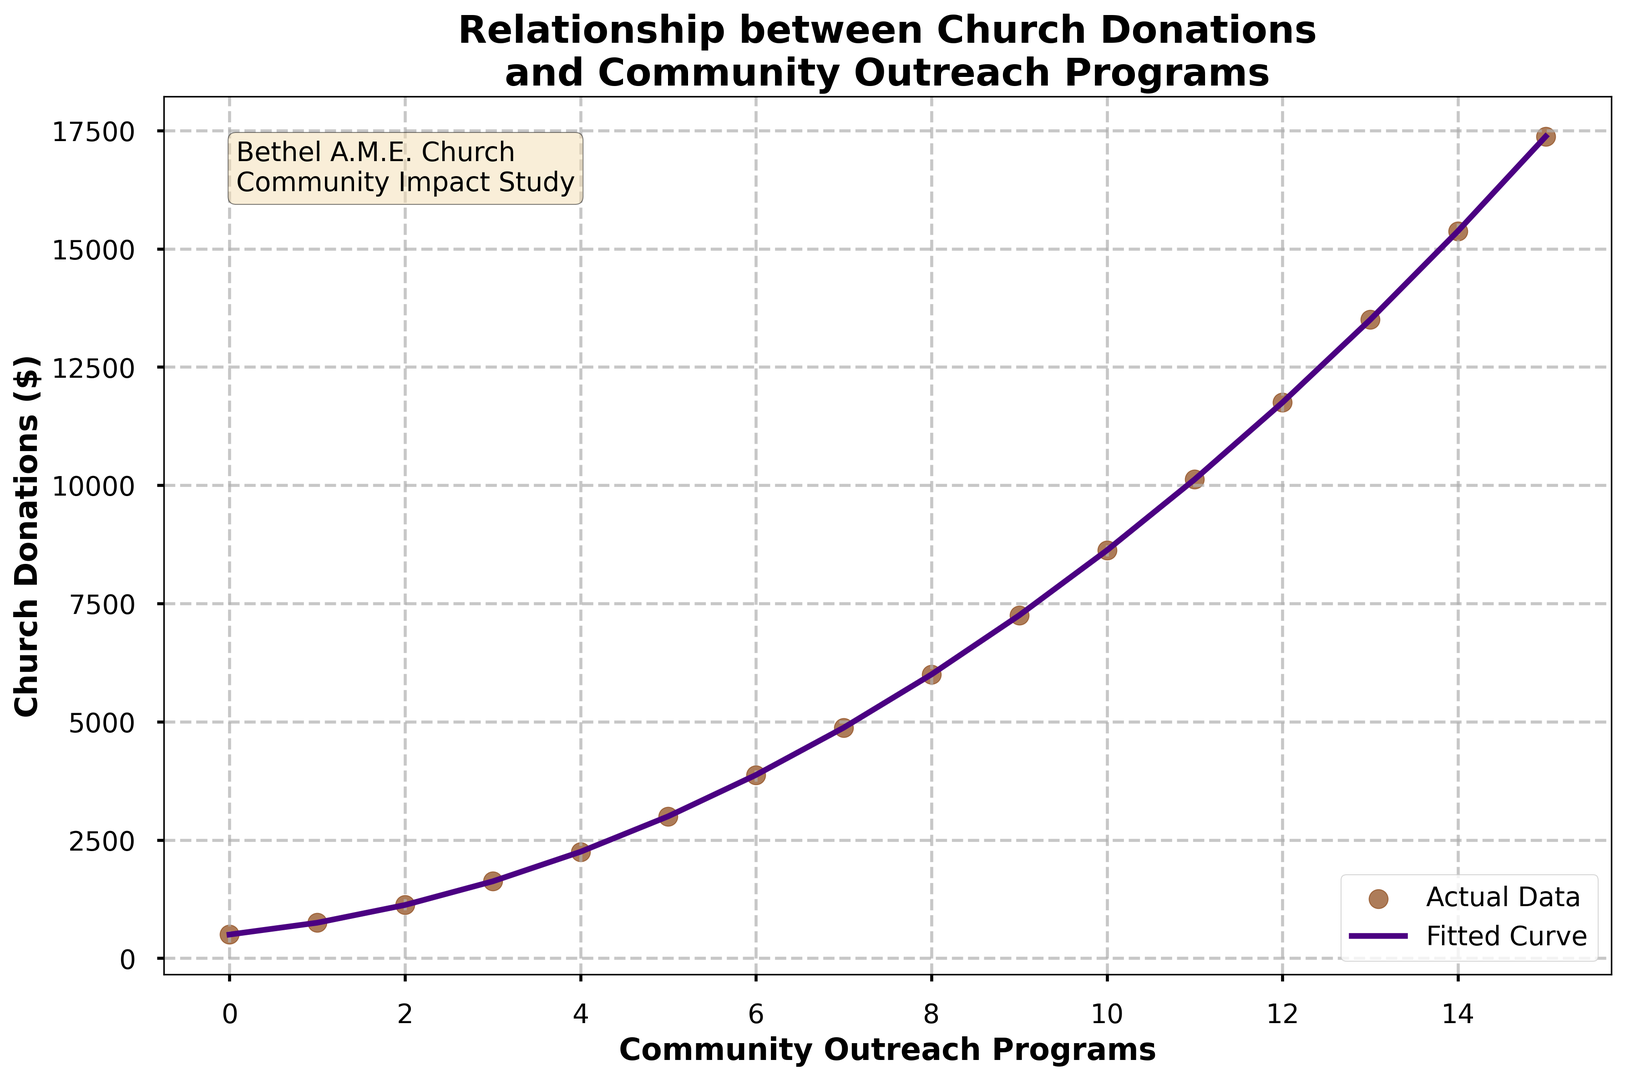How many community outreach programs have donations recorded? The x-axis of the plot represents the number of community outreach programs, which ranges from 0 to 15. Each integer value on this axis corresponds to a recorded donation amount on the y-axis.
Answer: 16 What is the highest donation amount recorded? The y-axis of the plot represents the donation amounts. By observing the highest point on this axis, the maximum donation amount can be determined. According to the plot, the highest donation amount is $17,375.
Answer: $17,375 At what quantity of community outreach programs does the church receive the largest donation? The plot shows the donations on the y-axis and outreach programs on the x-axis. The highest point on the curve indicates the maximum donation, which occurs at 15 outreach programs.
Answer: 15 What is the trend of donations as the number of outreach programs increases from 0 to 15? The scatter plot points and the fitted polynomial curve show the overall trend of donations with respect to outreach programs. Initially, donations rise steadily, then accelerate before leveling off somewhat. The polynomial curve fitted to the data provides a clear visualization of this trend.
Answer: Increasing, then leveling off What is the donation amount when there were 10 outreach programs? By locating 10 on the x-axis and moving vertically to the corresponding y-value, the donation amount can be determined. According to the plot, the donation amount when there were 10 outreach programs is approximately $8,625.
Answer: $8,625 How does the donation amount compare between 5 and 10 outreach programs? By observing the y-axis values for 5 and 10 outreach programs, we see the donation amount at 5 outreach programs is $3,000, and at 10 programs is $8,625. The donation amount for 10 programs is significantly higher than for 5 programs.
Answer: Higher at 10 programs Describe the color-coding used for the actual data points and the fitted curve. The plot uses different colors to distinguish between actual data points and the fitted curve. The actual data points are depicted in brown, while the fitted curve is shown in purple.
Answer: Brown for data points, purple for fitted curve What does the text box in the plot indicate? The text box located in the plot area provides context for the chart, stating "Bethel A.M.E. Church Community Impact Study," which indicates the origin and purpose of the data displayed.
Answer: Bethel A.M.E. Church Community Impact Study Which outreach program count shows the steepest increase in donation amount? The steepest increase in the fitted polynomial curve can be observed by the segment with the sharpest upward slope. This seems to occur around the transition from 2 to 3 outreach programs, where the donation amount rises notably.
Answer: Around 2 to 3 programs What is the average donation amount for outreach programs 5 through 10? To find the average, sum the donation amounts for outreach programs 5, 6, 7, 8, 9, and 10, and then divide by the number of data points. The sums are $3,000, $3,875, $4,875, $6,000, $7,250, $8,625. Average is (3000+3875+4875+6000+7250+8625)/6 = $5,271.
Answer: $5,271 